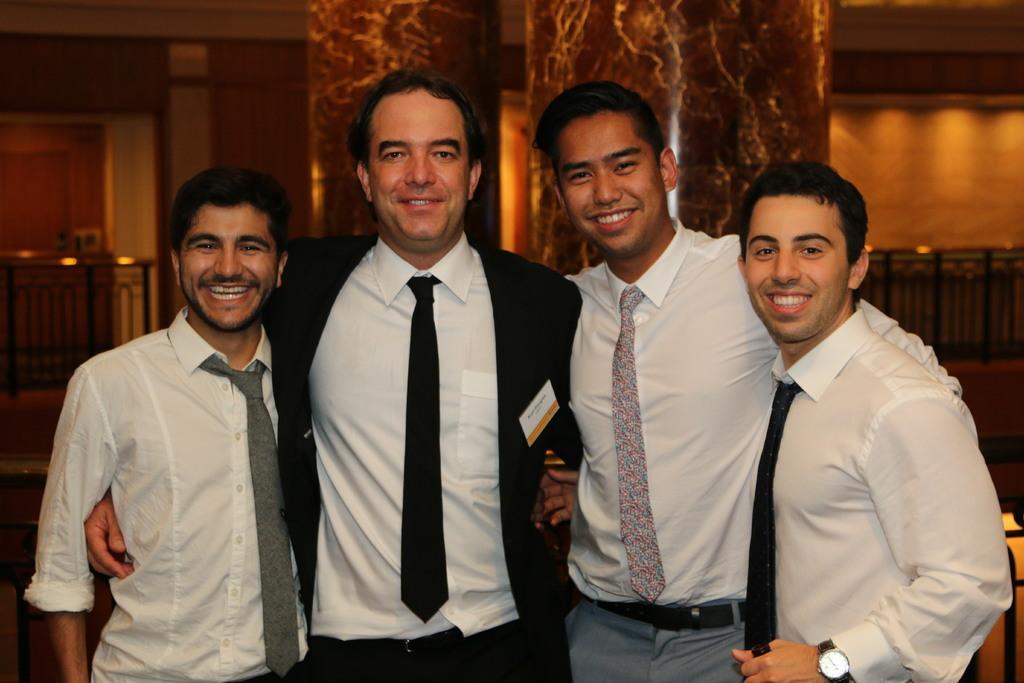In one or two sentences, can you explain what this image depicts? In the foreground I can see four men and there is a smile on their faces. I can see a man in the middle of the picture is wearing a suit and a tie. This is looking like a metal fence on the left side. 